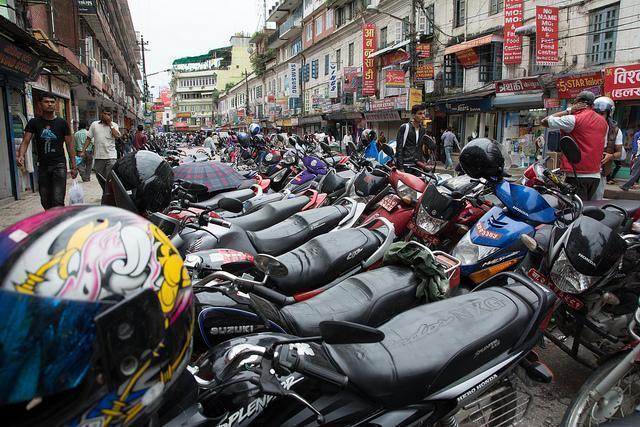The motorbikes on this bustling city street are present in which country?
Select the accurate answer and provide explanation: 'Answer: answer
Rationale: rationale.'
Options: China, thailand, vietnam, india. Answer: india.
Rationale: That country is known to have many of those vehicles. there are many very dark-skinned men who don't have that east-asian look, thus the selected country. 